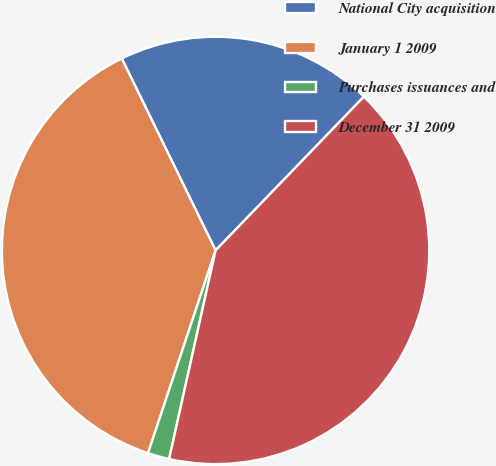Convert chart. <chart><loc_0><loc_0><loc_500><loc_500><pie_chart><fcel>National City acquisition<fcel>January 1 2009<fcel>Purchases issuances and<fcel>December 31 2009<nl><fcel>19.45%<fcel>37.65%<fcel>1.63%<fcel>41.28%<nl></chart> 